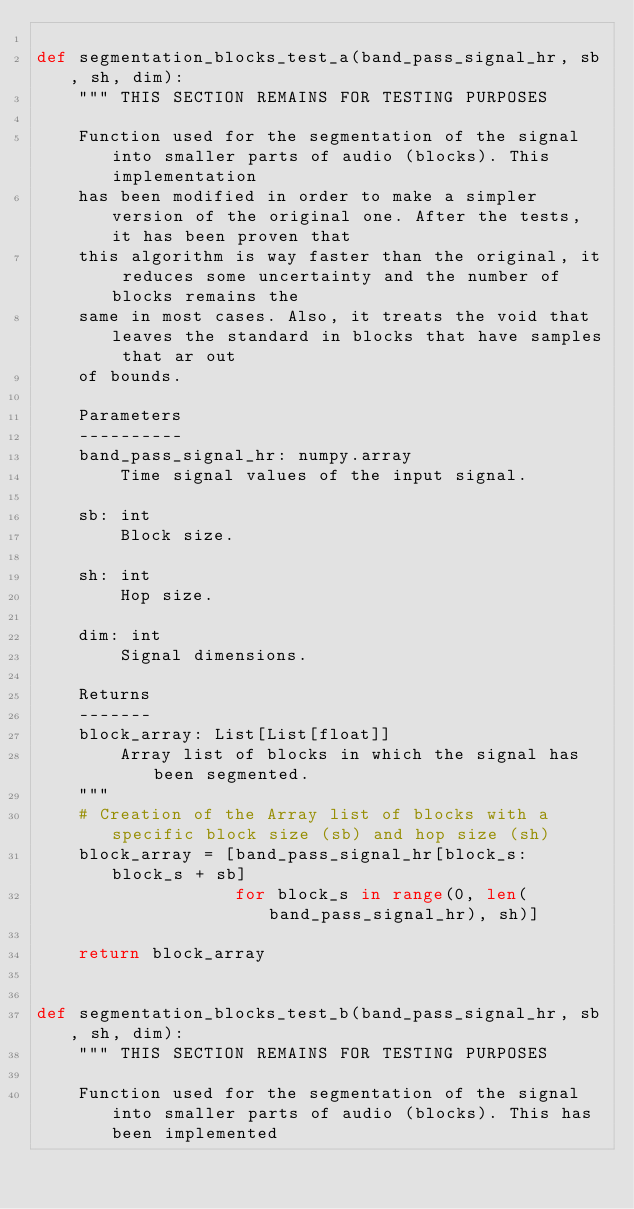Convert code to text. <code><loc_0><loc_0><loc_500><loc_500><_Python_>
def segmentation_blocks_test_a(band_pass_signal_hr, sb, sh, dim):
    """ THIS SECTION REMAINS FOR TESTING PURPOSES

    Function used for the segmentation of the signal into smaller parts of audio (blocks). This implementation
    has been modified in order to make a simpler version of the original one. After the tests, it has been proven that
    this algorithm is way faster than the original, it reduces some uncertainty and the number of blocks remains the
    same in most cases. Also, it treats the void that leaves the standard in blocks that have samples that ar out
    of bounds.

    Parameters
    ----------
    band_pass_signal_hr: numpy.array
        Time signal values of the input signal.

    sb: int
        Block size.

    sh: int
        Hop size.

    dim: int
        Signal dimensions.

    Returns
    -------
    block_array: List[List[float]]
        Array list of blocks in which the signal has been segmented.
    """
    # Creation of the Array list of blocks with a specific block size (sb) and hop size (sh)
    block_array = [band_pass_signal_hr[block_s: block_s + sb]
                   for block_s in range(0, len(band_pass_signal_hr), sh)]

    return block_array


def segmentation_blocks_test_b(band_pass_signal_hr, sb, sh, dim):
    """ THIS SECTION REMAINS FOR TESTING PURPOSES

    Function used for the segmentation of the signal into smaller parts of audio (blocks). This has been implemented</code> 